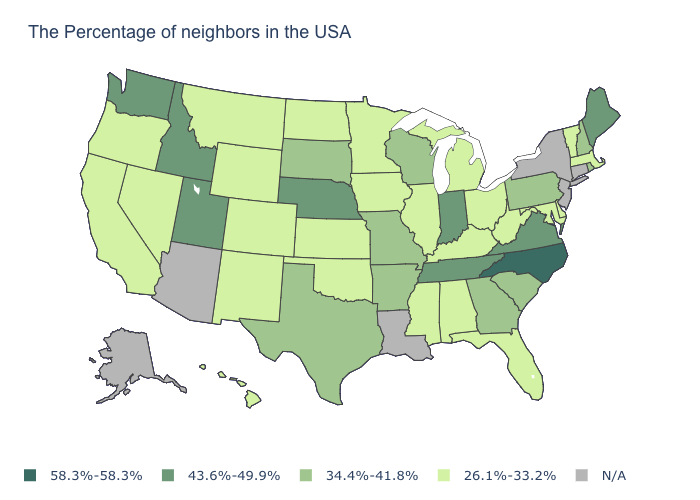Does the map have missing data?
Write a very short answer. Yes. What is the value of New Jersey?
Concise answer only. N/A. Name the states that have a value in the range 34.4%-41.8%?
Concise answer only. Rhode Island, New Hampshire, Pennsylvania, South Carolina, Georgia, Wisconsin, Missouri, Arkansas, Texas, South Dakota. Which states have the lowest value in the USA?
Be succinct. Massachusetts, Vermont, Delaware, Maryland, West Virginia, Ohio, Florida, Michigan, Kentucky, Alabama, Illinois, Mississippi, Minnesota, Iowa, Kansas, Oklahoma, North Dakota, Wyoming, Colorado, New Mexico, Montana, Nevada, California, Oregon, Hawaii. Is the legend a continuous bar?
Write a very short answer. No. What is the value of Arizona?
Write a very short answer. N/A. Which states have the lowest value in the USA?
Keep it brief. Massachusetts, Vermont, Delaware, Maryland, West Virginia, Ohio, Florida, Michigan, Kentucky, Alabama, Illinois, Mississippi, Minnesota, Iowa, Kansas, Oklahoma, North Dakota, Wyoming, Colorado, New Mexico, Montana, Nevada, California, Oregon, Hawaii. Name the states that have a value in the range 58.3%-58.3%?
Quick response, please. North Carolina. What is the value of South Carolina?
Short answer required. 34.4%-41.8%. Which states have the lowest value in the USA?
Quick response, please. Massachusetts, Vermont, Delaware, Maryland, West Virginia, Ohio, Florida, Michigan, Kentucky, Alabama, Illinois, Mississippi, Minnesota, Iowa, Kansas, Oklahoma, North Dakota, Wyoming, Colorado, New Mexico, Montana, Nevada, California, Oregon, Hawaii. Which states have the highest value in the USA?
Give a very brief answer. North Carolina. Among the states that border New Mexico , which have the lowest value?
Be succinct. Oklahoma, Colorado. Which states have the lowest value in the USA?
Give a very brief answer. Massachusetts, Vermont, Delaware, Maryland, West Virginia, Ohio, Florida, Michigan, Kentucky, Alabama, Illinois, Mississippi, Minnesota, Iowa, Kansas, Oklahoma, North Dakota, Wyoming, Colorado, New Mexico, Montana, Nevada, California, Oregon, Hawaii. Name the states that have a value in the range 26.1%-33.2%?
Write a very short answer. Massachusetts, Vermont, Delaware, Maryland, West Virginia, Ohio, Florida, Michigan, Kentucky, Alabama, Illinois, Mississippi, Minnesota, Iowa, Kansas, Oklahoma, North Dakota, Wyoming, Colorado, New Mexico, Montana, Nevada, California, Oregon, Hawaii. 